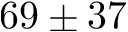Convert formula to latex. <formula><loc_0><loc_0><loc_500><loc_500>6 9 \pm 3 7</formula> 